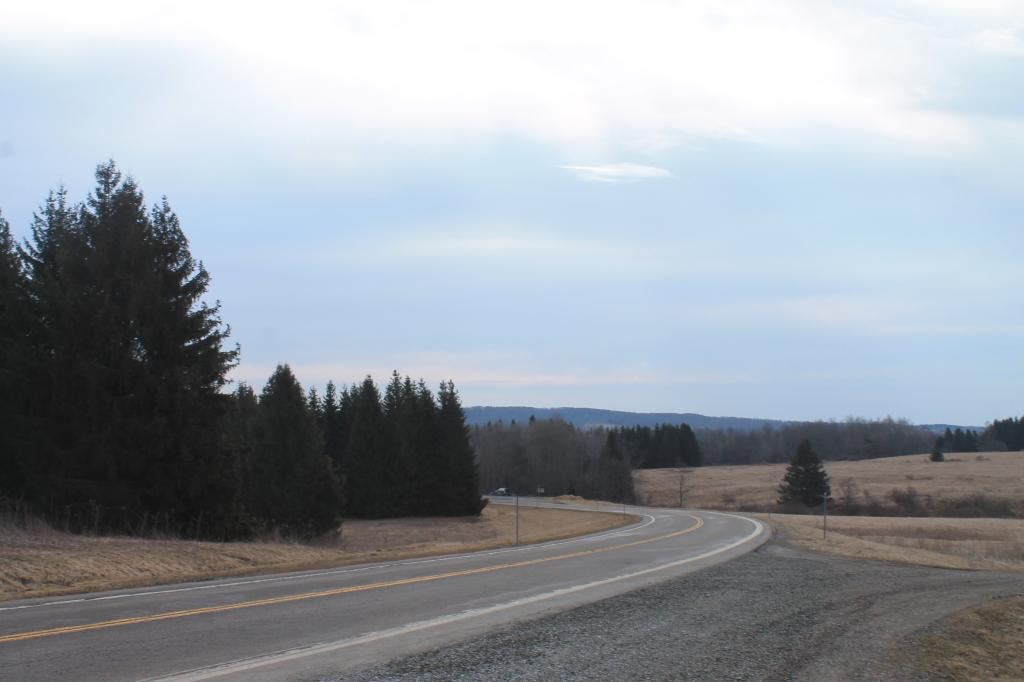What is the main feature of the image? There is a road in the image. What can be seen beside the road? Trees are present beside the road. What else is visible in the image? There are poles in the image. What can be seen below the road and poles? The ground is visible in the image. What is visible above the road, trees, and poles? The sky is visible in the image. What type of hair can be seen on the trees in the image? There is no hair present on the trees in the image; they are natural trees with leaves or branches. 